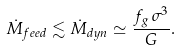Convert formula to latex. <formula><loc_0><loc_0><loc_500><loc_500>\dot { M } _ { f e e d } \lesssim \dot { M } _ { d y n } \simeq \frac { f _ { g } \, \sigma ^ { 3 } } { G } .</formula> 